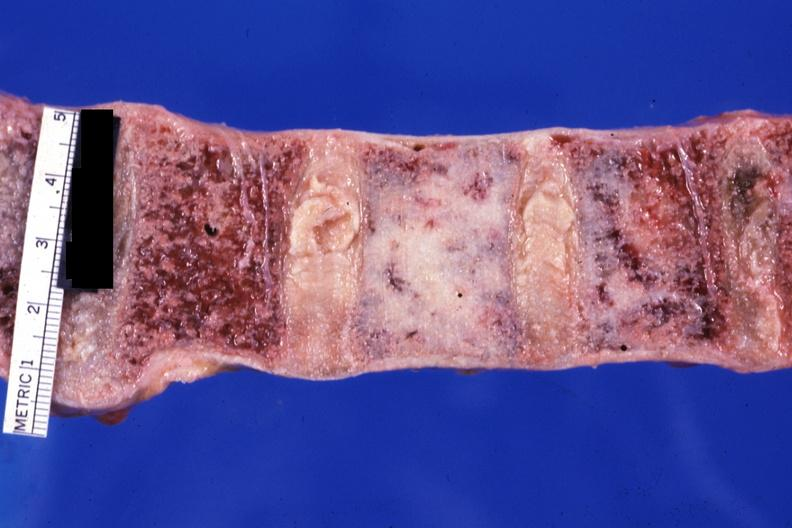what does close-up look?
Answer the question using a single word or phrase. Up looks like ivory vertebra of breast carcinoma 